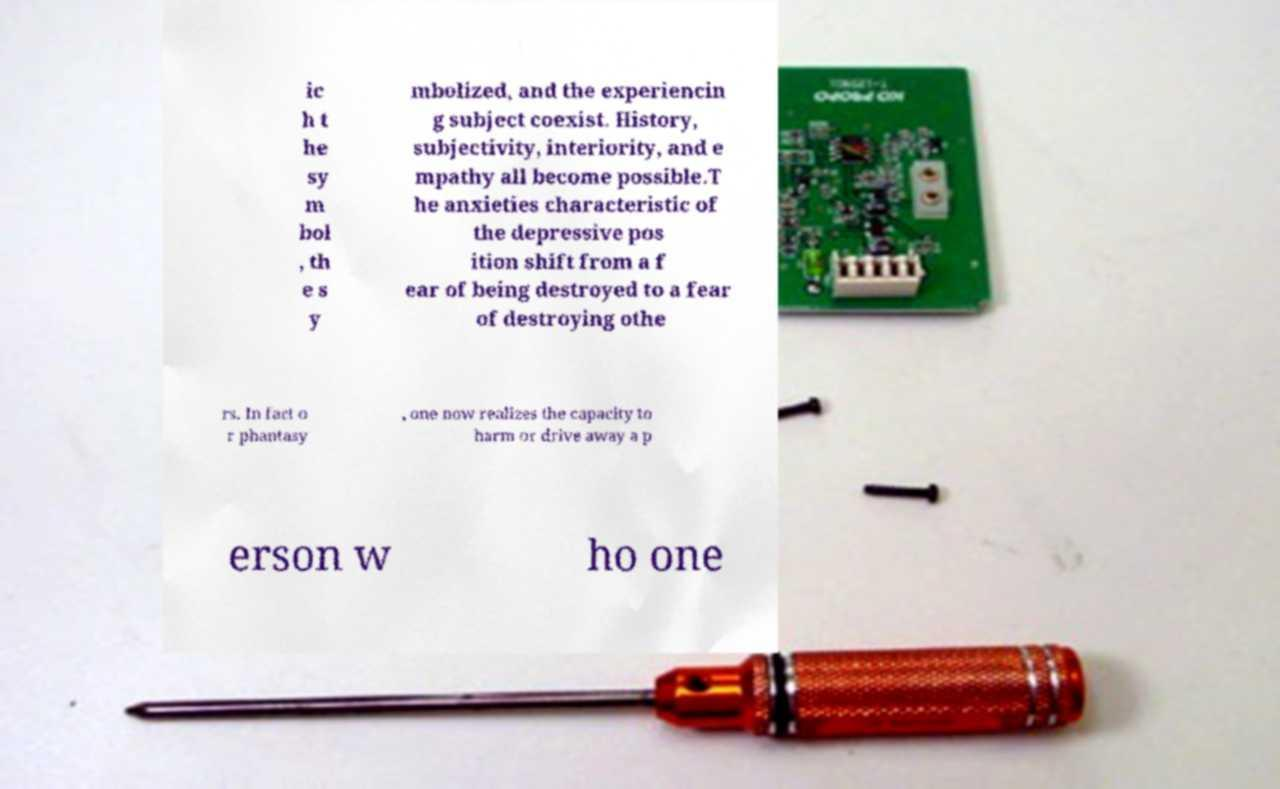Could you extract and type out the text from this image? ic h t he sy m bol , th e s y mbolized, and the experiencin g subject coexist. History, subjectivity, interiority, and e mpathy all become possible.T he anxieties characteristic of the depressive pos ition shift from a f ear of being destroyed to a fear of destroying othe rs. In fact o r phantasy , one now realizes the capacity to harm or drive away a p erson w ho one 